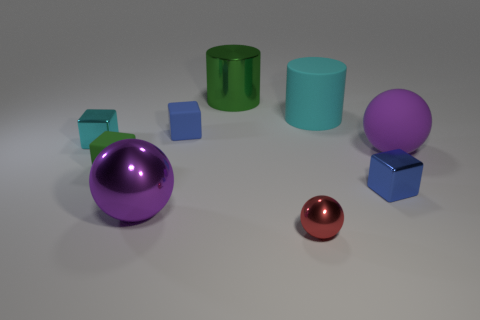There is a large object that is the same color as the rubber ball; what shape is it?
Your answer should be compact. Sphere. What material is the big cyan cylinder?
Give a very brief answer. Rubber. The other purple thing that is the same shape as the big purple rubber object is what size?
Make the answer very short. Large. Is the big matte sphere the same color as the large matte cylinder?
Ensure brevity in your answer.  No. What number of other objects are the same material as the big green cylinder?
Your answer should be compact. 4. Is the number of cyan metal objects in front of the tiny blue metallic cube the same as the number of cylinders?
Your answer should be compact. No. There is a blue thing that is behind the green cube; is it the same size as the green cylinder?
Provide a short and direct response. No. How many small blue matte objects are behind the small red metallic sphere?
Your response must be concise. 1. What is the material of the small thing that is behind the purple metallic ball and in front of the tiny green rubber object?
Your response must be concise. Metal. What number of large things are either cyan cylinders or spheres?
Give a very brief answer. 3. 